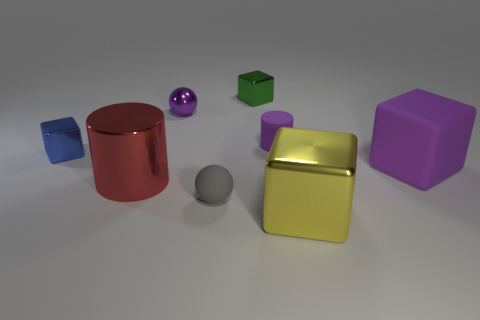Subtract all green blocks. How many blocks are left? 3 Add 2 blue matte things. How many objects exist? 10 Subtract all green cubes. How many cubes are left? 3 Add 2 tiny balls. How many tiny balls exist? 4 Subtract 0 brown cubes. How many objects are left? 8 Subtract all cylinders. How many objects are left? 6 Subtract 2 cylinders. How many cylinders are left? 0 Subtract all red spheres. Subtract all red blocks. How many spheres are left? 2 Subtract all large purple blocks. Subtract all big green cubes. How many objects are left? 7 Add 4 tiny purple rubber cylinders. How many tiny purple rubber cylinders are left? 5 